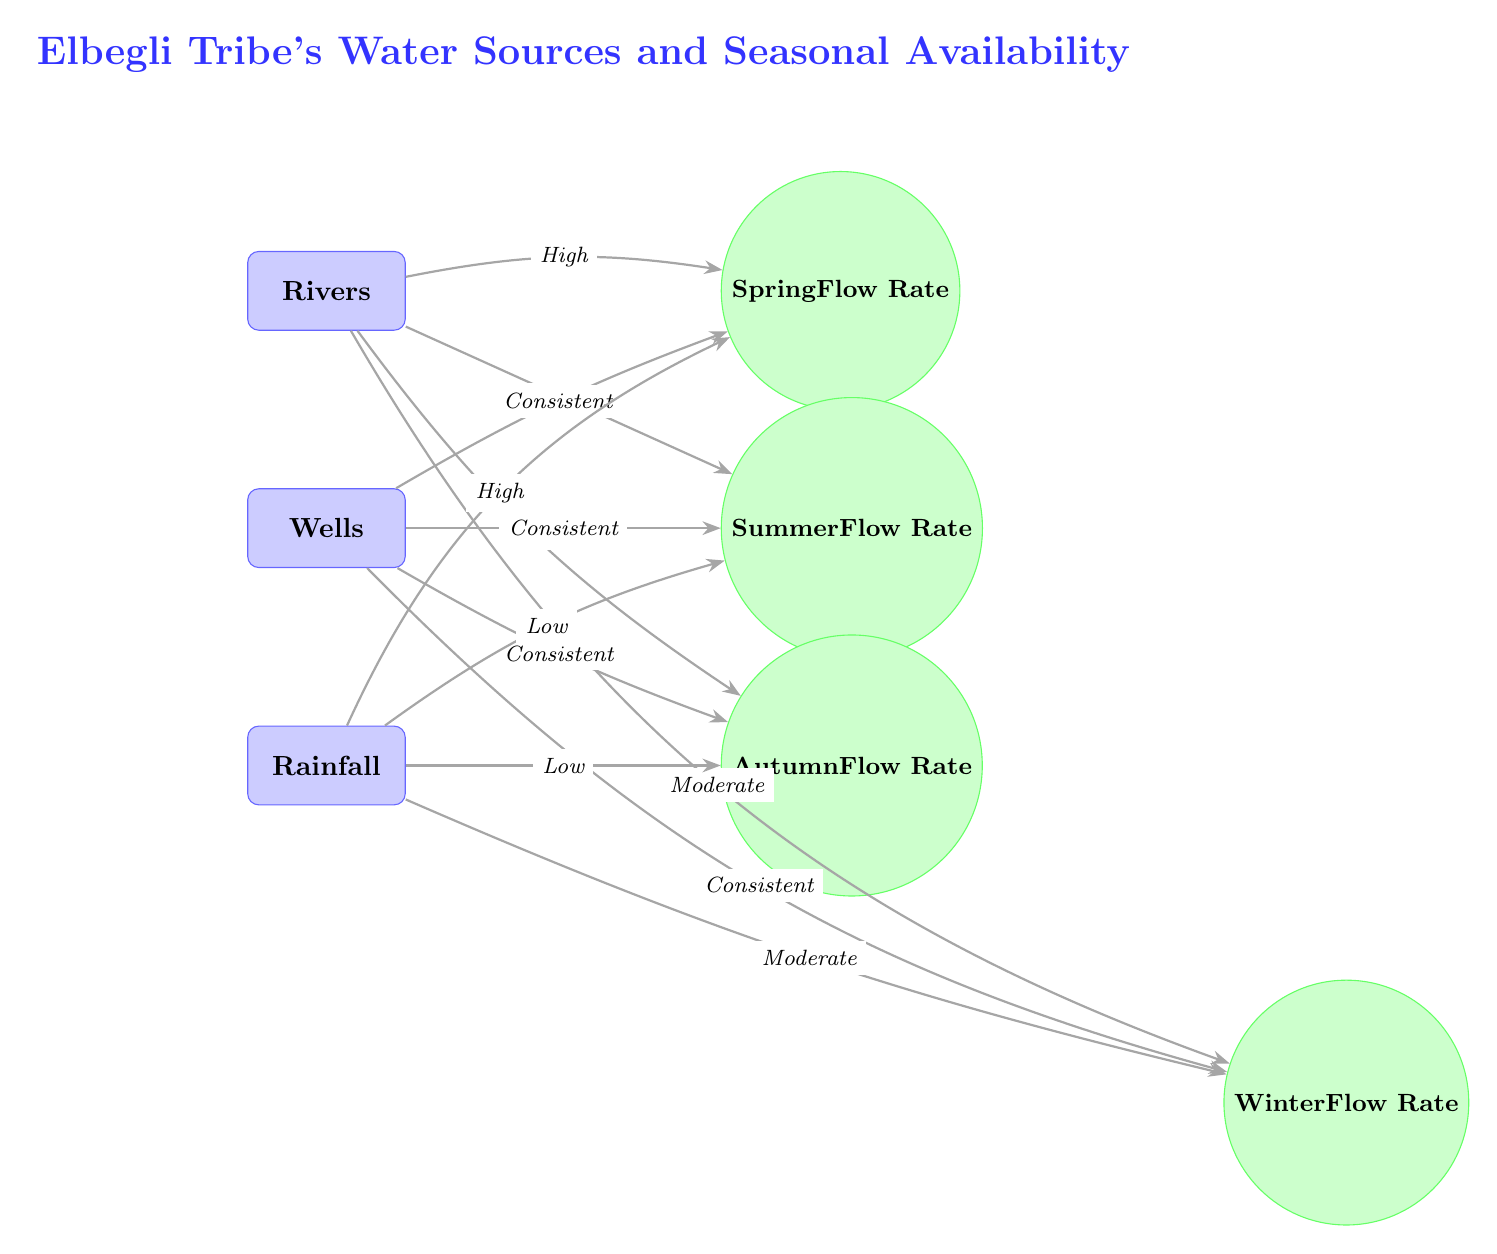What are the three main water sources depicted in the diagram? The diagram shows three main water sources: Rivers, Wells, and Rainfall. This is identified directly from the labeled nodes in the diagram.
Answer: Rivers, Wells, Rainfall What is the flow rate for Rivers in Spring? The flow rate for Rivers in Spring is labeled as "High" in the diagram, which is indicated by the edge connecting the Rivers node to the Spring node.
Answer: High How is the flow rate for Wells described in Autumn? The flow rate for Wells in Autumn is described as "Consistent." This is determined by examining the edge connecting the Wells node to the Autumn node, which notes the flow rate.
Answer: Consistent Which season has the lowest flow rate for Rainfall? The season with the lowest flow rate for Rainfall is Summer, indicated by the edge labeled "Low" connecting the Rainfall node to the Summer node.
Answer: Low Are the flow rates for Wells different in all seasons? No, the flow rates for Wells are consistent across all seasons, as indicated by the edges connecting the Wells node to each of the seasonal nodes. All edges are labeled "Consistent."
Answer: No What does the diagram suggest about Rainfall in Winter? The diagram indicates that the flow rate for Rainfall in Winter is "Moderate," as shown by the edge connecting the Rainfall node to the Winter node.
Answer: Moderate How many total nodes are there in the diagram related to water sources? There are three nodes related to water sources (Rivers, Wells, Rainfall) in the diagram. This is determined by simply counting the water source nodes present in the diagram.
Answer: 3 What is the description of Rivers during Autumn? The description of Rivers during Autumn is "Low," which can be found on the edge connecting the Rivers node to the Autumn node in the diagram.
Answer: Low What type of relationship do all seasonal flow rates for Wells have? The relationship for all seasonal flow rates for Wells is "Consistent," as observed in the edges directing from the Wells node to each of the seasonal nodes.
Answer: Consistent 